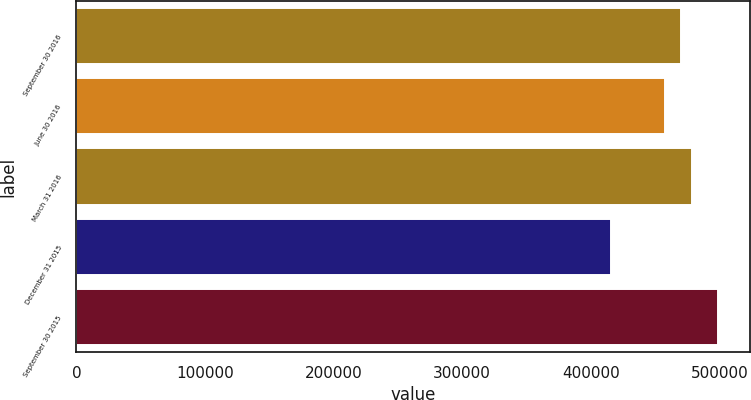Convert chart. <chart><loc_0><loc_0><loc_500><loc_500><bar_chart><fcel>September 30 2016<fcel>June 30 2016<fcel>March 31 2016<fcel>December 31 2015<fcel>September 30 2015<nl><fcel>470222<fcel>457777<fcel>478574<fcel>415346<fcel>498871<nl></chart> 